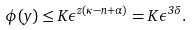Convert formula to latex. <formula><loc_0><loc_0><loc_500><loc_500>\phi ( y ) \leq K \epsilon ^ { z ( \kappa - n + \alpha ) } = K \epsilon ^ { 3 \delta } .</formula> 